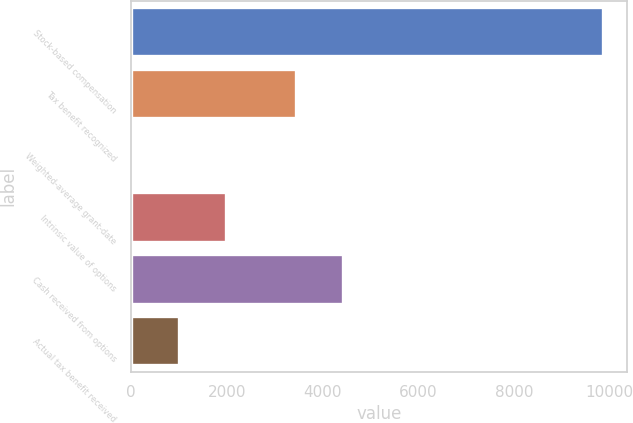Convert chart. <chart><loc_0><loc_0><loc_500><loc_500><bar_chart><fcel>Stock-based compensation<fcel>Tax benefit recognized<fcel>Weighted-average grant-date<fcel>Intrinsic value of options<fcel>Cash received from options<fcel>Actual tax benefit received<nl><fcel>9860<fcel>3451<fcel>5.5<fcel>1976.4<fcel>4436.45<fcel>990.95<nl></chart> 